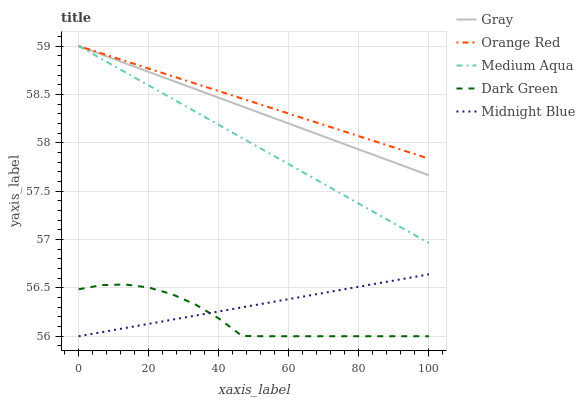Does Dark Green have the minimum area under the curve?
Answer yes or no. Yes. Does Orange Red have the maximum area under the curve?
Answer yes or no. Yes. Does Midnight Blue have the minimum area under the curve?
Answer yes or no. No. Does Midnight Blue have the maximum area under the curve?
Answer yes or no. No. Is Midnight Blue the smoothest?
Answer yes or no. Yes. Is Dark Green the roughest?
Answer yes or no. Yes. Is Medium Aqua the smoothest?
Answer yes or no. No. Is Medium Aqua the roughest?
Answer yes or no. No. Does Midnight Blue have the lowest value?
Answer yes or no. Yes. Does Medium Aqua have the lowest value?
Answer yes or no. No. Does Orange Red have the highest value?
Answer yes or no. Yes. Does Midnight Blue have the highest value?
Answer yes or no. No. Is Dark Green less than Medium Aqua?
Answer yes or no. Yes. Is Orange Red greater than Midnight Blue?
Answer yes or no. Yes. Does Midnight Blue intersect Dark Green?
Answer yes or no. Yes. Is Midnight Blue less than Dark Green?
Answer yes or no. No. Is Midnight Blue greater than Dark Green?
Answer yes or no. No. Does Dark Green intersect Medium Aqua?
Answer yes or no. No. 